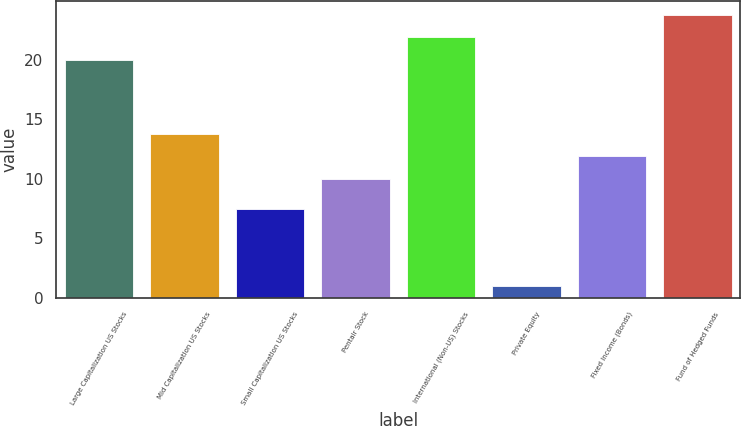Convert chart. <chart><loc_0><loc_0><loc_500><loc_500><bar_chart><fcel>Large Capitalization US Stocks<fcel>Mid Capitalization US Stocks<fcel>Small Capitalization US Stocks<fcel>Pentair Stock<fcel>International (Non-US) Stocks<fcel>Private Equity<fcel>Fixed Income (Bonds)<fcel>Fund of Hedged Funds<nl><fcel>20<fcel>13.8<fcel>7.5<fcel>10<fcel>21.9<fcel>1<fcel>11.9<fcel>23.8<nl></chart> 